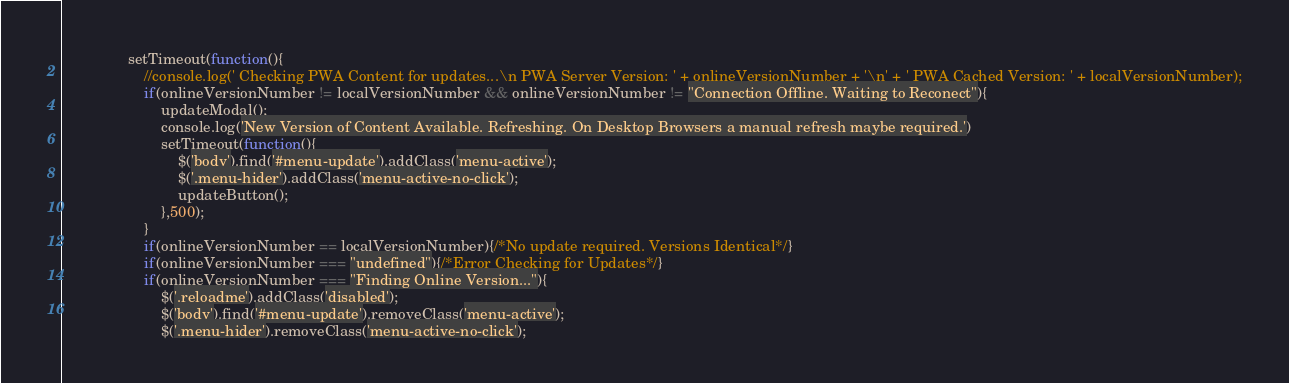Convert code to text. <code><loc_0><loc_0><loc_500><loc_500><_JavaScript_>                setTimeout(function(){
                    //console.log(' Checking PWA Content for updates...\n PWA Server Version: ' + onlineVersionNumber + '\n' + ' PWA Cached Version: ' + localVersionNumber);
                    if(onlineVersionNumber != localVersionNumber && onlineVersionNumber != "Connection Offline. Waiting to Reconect"){
                        updateModal();
                        console.log('New Version of Content Available. Refreshing. On Desktop Browsers a manual refresh maybe required.')
                        setTimeout(function(){
                            $('body').find('#menu-update').addClass('menu-active');
                            $('.menu-hider').addClass('menu-active-no-click');    
                            updateButton();
                        },500);
                    }     
                    if(onlineVersionNumber == localVersionNumber){/*No update required. Versions Identical*/}    
                    if(onlineVersionNumber === "undefined"){/*Error Checking for Updates*/}    
                    if(onlineVersionNumber === "Finding Online Version..."){
                        $('.reloadme').addClass('disabled'); 
                        $('body').find('#menu-update').removeClass('menu-active');
                        $('.menu-hider').removeClass('menu-active-no-click');                </code> 